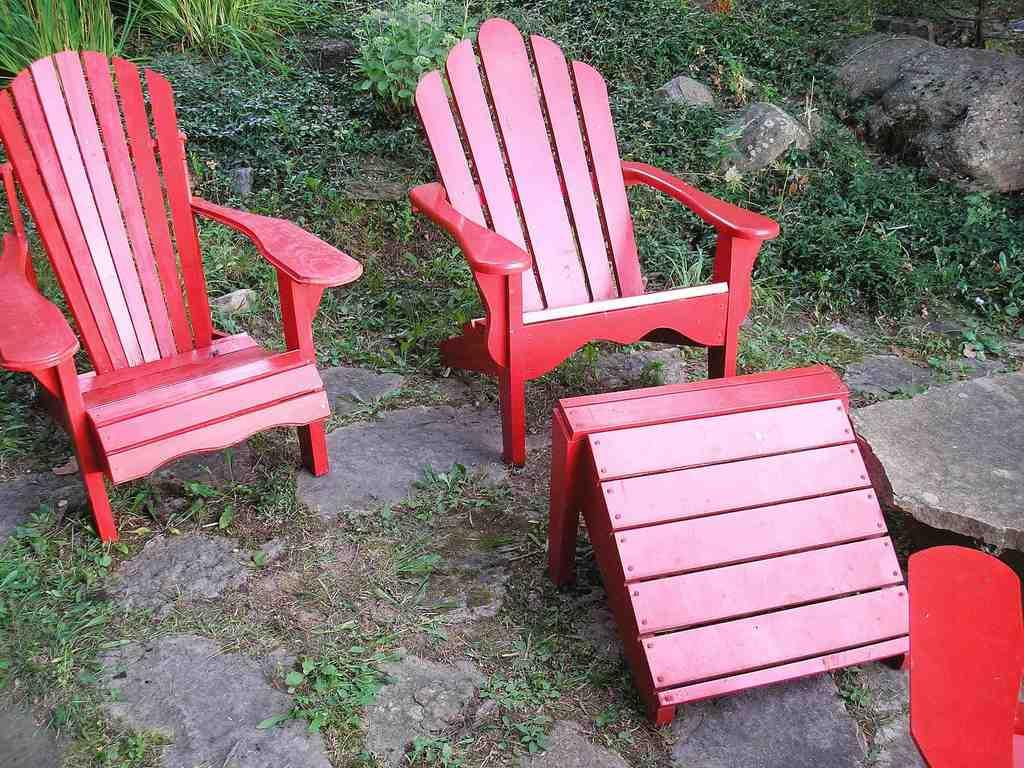What type of furniture is visible in the image? There are chairs in the image. What color is the prominent object in the image? There is a red color object in the image. What type of ground surface is visible in the image? There is grass on the ground in the image. What type of vegetation can be seen in the background of the image? There are small plants in the background of the image. What type of natural elements are present in the background of the image? There are stones and rocks in the background of the image. What type of flesh can be seen in the image? There is no flesh present in the image; it features chairs, a red object, grass, small plants, stones, and rocks. Is there a story being told in the image? The image does not depict a story; it is a static representation of the mentioned objects and elements. 